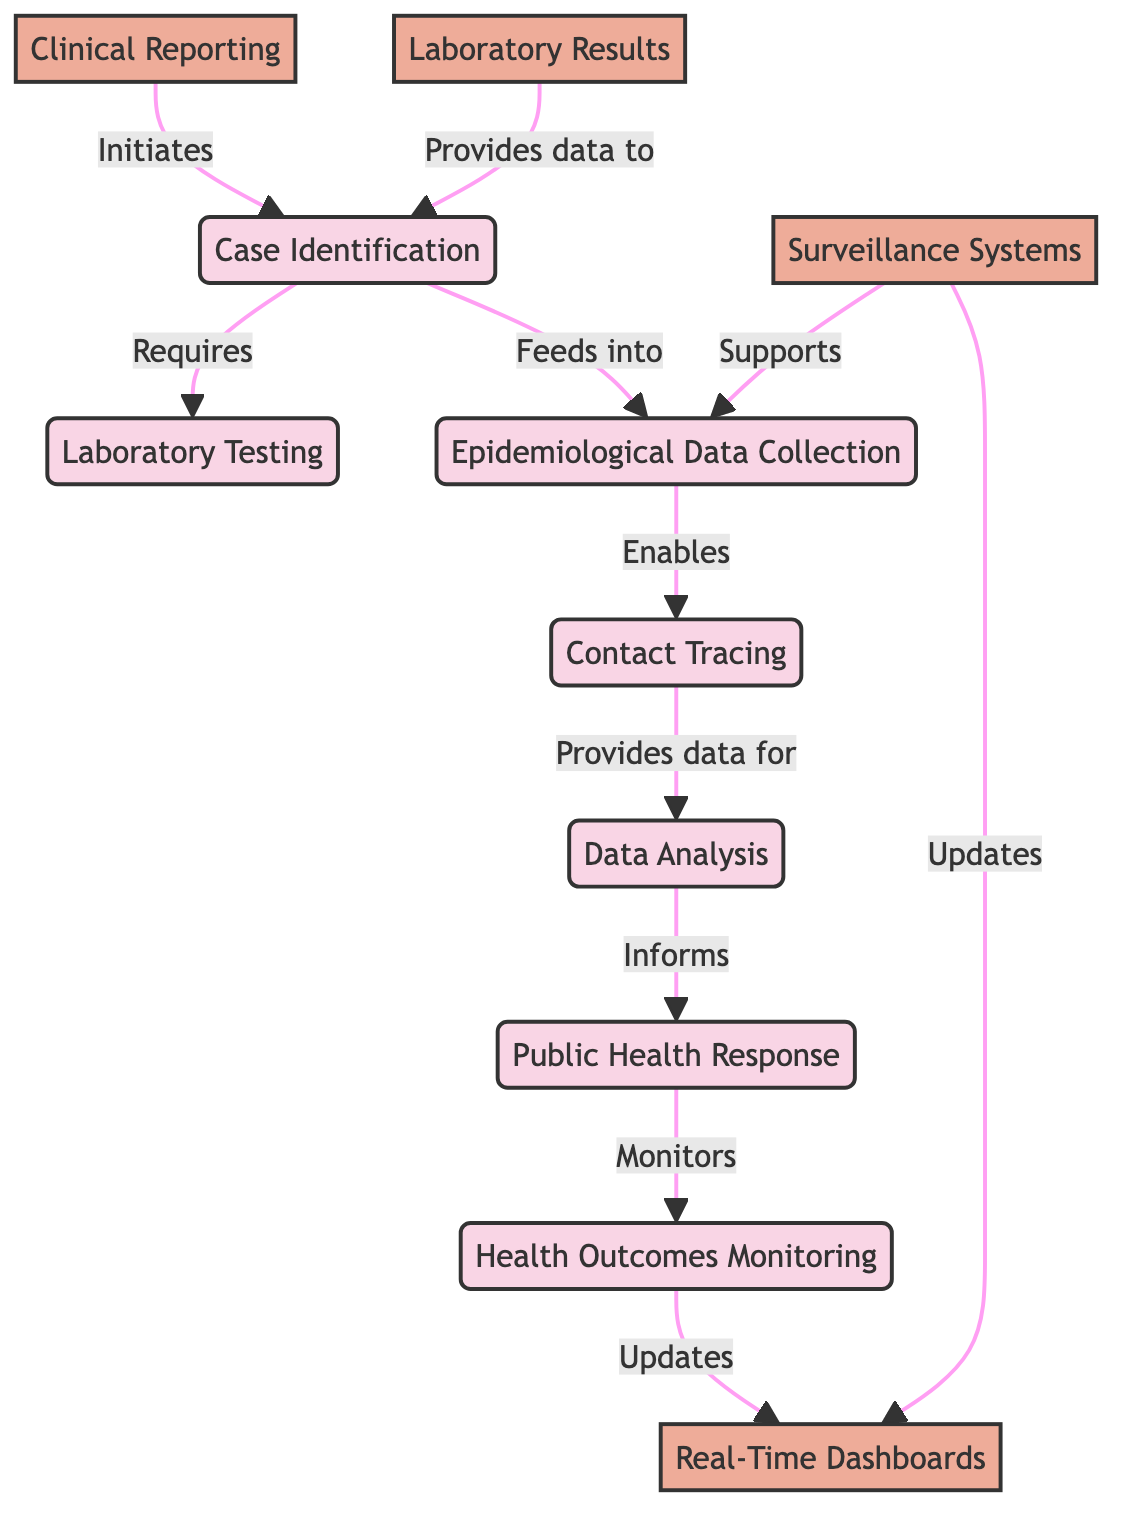What is the first step in the epidemiological investigation workflow? The diagram shows that the first step is case identification, as indicated by the directed arrow coming from clinical reporting.
Answer: Case Identification Which node requires laboratory testing? According to the flow from clinical reporting to case identification, case identification is the node that requires laboratory testing to proceed.
Answer: Case Identification How many data sources are represented in the diagram? The diagram includes four data sources: Clinical Reporting, Laboratory Results, Surveillance Systems, and Real-Time Dashboards. By counting them, we find there are four distinct data sources.
Answer: Four Which process is informed by data analysis? The diagram illustrates that data analysis informs the public health response as indicated by the directed arrow connecting data analysis to public health response.
Answer: Public Health Response What supports epidemiological data collection? The diagram indicates that Surveillance Systems support epidemiological data collection through a direct link, as shown by the arrow from surveillance systems to epi data collection.
Answer: Surveillance Systems Which process directly feeds into contact tracing? Epi data collection, as depicted in the diagram, directly enables contact tracing, signifying that this process is essential for moving forward to contact tracing.
Answer: Epidemiological Data Collection What is the final monitoring step in the workflow? The diagram shows that health outcomes monitoring is the final step in the workflow, as indicated by the lack of any further nodes after it.
Answer: Health Outcomes Monitoring How many processes are illustrated in the diagram? By counting the processes displayed in the diagram, we find there are six distinct processes: Case Identification, Laboratory Testing, Epidemiological Data Collection, Contact Tracing, Data Analysis, and Public Health Response.
Answer: Six Which feedback loops exist in the diagram? The diagram shows feedback loops with dashboards updating from both surveillance systems and health outcomes, indicating they provide valuable real-time data impacting previous processes.
Answer: Dashboards 